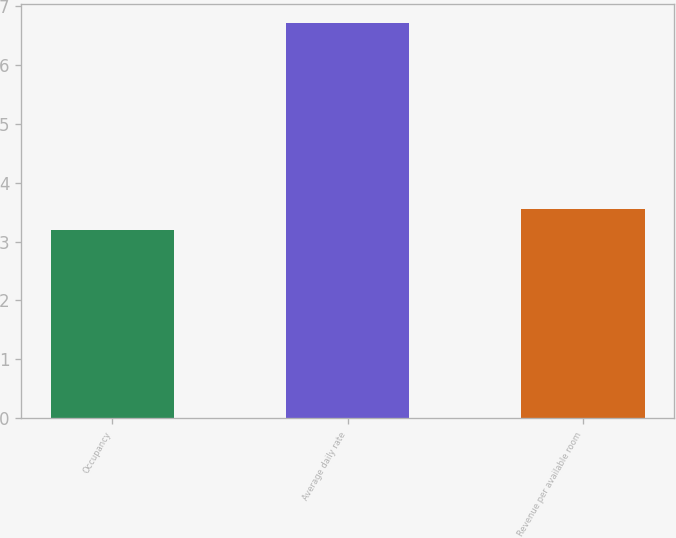Convert chart to OTSL. <chart><loc_0><loc_0><loc_500><loc_500><bar_chart><fcel>Occupancy<fcel>Average daily rate<fcel>Revenue per available room<nl><fcel>3.2<fcel>6.7<fcel>3.55<nl></chart> 